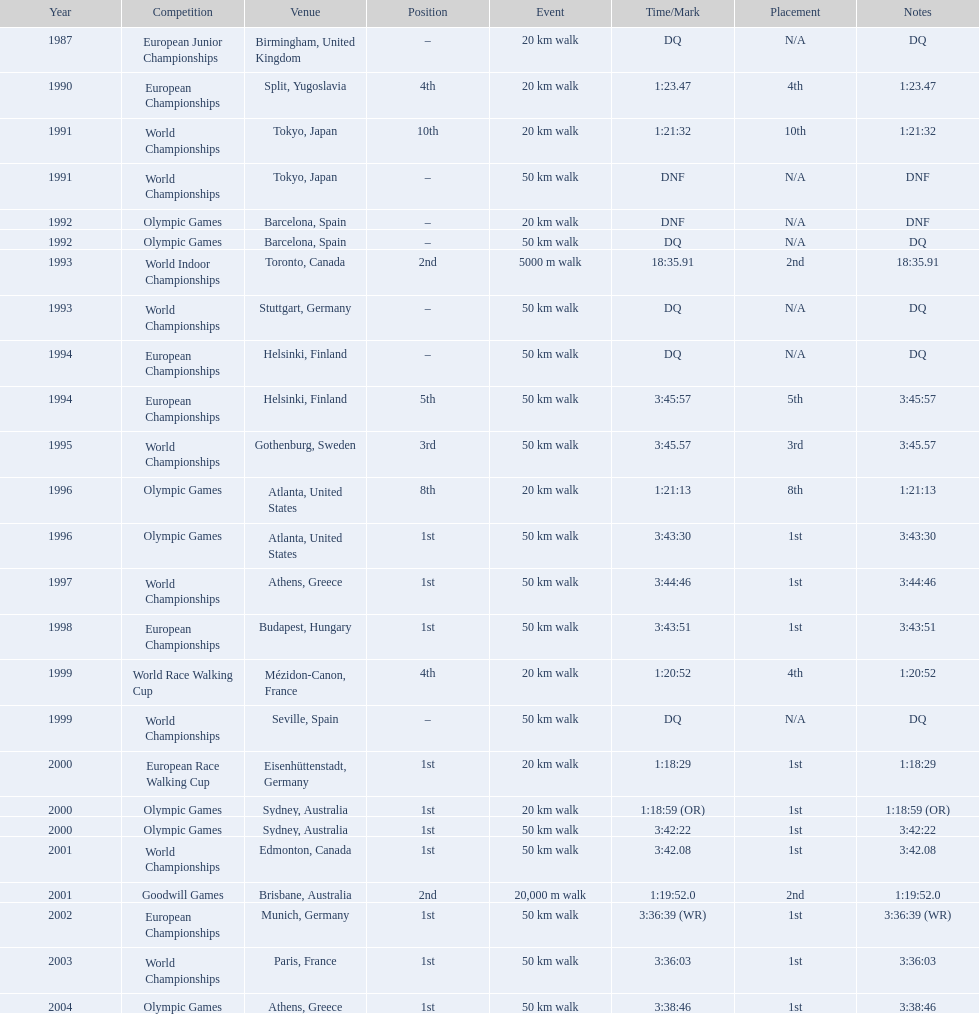Which venue is listed the most? Athens, Greece. 